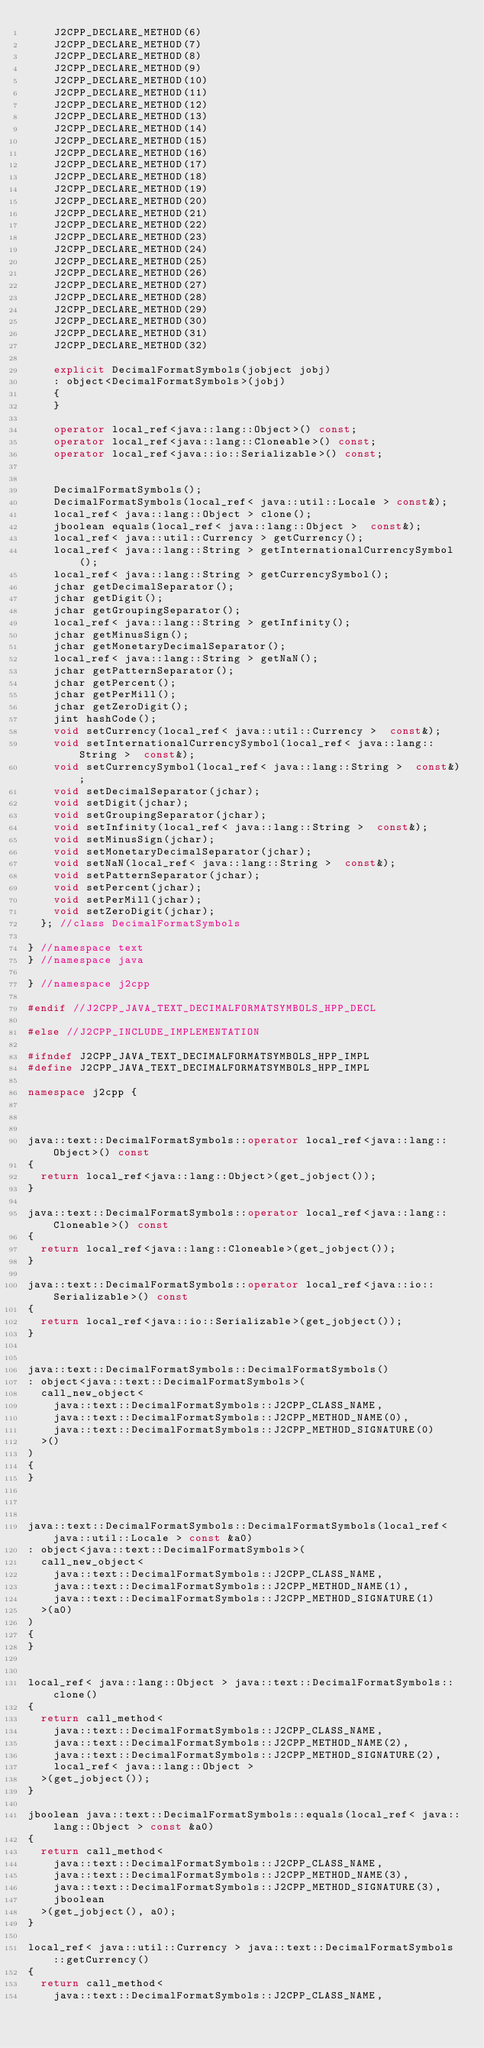<code> <loc_0><loc_0><loc_500><loc_500><_C++_>		J2CPP_DECLARE_METHOD(6)
		J2CPP_DECLARE_METHOD(7)
		J2CPP_DECLARE_METHOD(8)
		J2CPP_DECLARE_METHOD(9)
		J2CPP_DECLARE_METHOD(10)
		J2CPP_DECLARE_METHOD(11)
		J2CPP_DECLARE_METHOD(12)
		J2CPP_DECLARE_METHOD(13)
		J2CPP_DECLARE_METHOD(14)
		J2CPP_DECLARE_METHOD(15)
		J2CPP_DECLARE_METHOD(16)
		J2CPP_DECLARE_METHOD(17)
		J2CPP_DECLARE_METHOD(18)
		J2CPP_DECLARE_METHOD(19)
		J2CPP_DECLARE_METHOD(20)
		J2CPP_DECLARE_METHOD(21)
		J2CPP_DECLARE_METHOD(22)
		J2CPP_DECLARE_METHOD(23)
		J2CPP_DECLARE_METHOD(24)
		J2CPP_DECLARE_METHOD(25)
		J2CPP_DECLARE_METHOD(26)
		J2CPP_DECLARE_METHOD(27)
		J2CPP_DECLARE_METHOD(28)
		J2CPP_DECLARE_METHOD(29)
		J2CPP_DECLARE_METHOD(30)
		J2CPP_DECLARE_METHOD(31)
		J2CPP_DECLARE_METHOD(32)

		explicit DecimalFormatSymbols(jobject jobj)
		: object<DecimalFormatSymbols>(jobj)
		{
		}

		operator local_ref<java::lang::Object>() const;
		operator local_ref<java::lang::Cloneable>() const;
		operator local_ref<java::io::Serializable>() const;


		DecimalFormatSymbols();
		DecimalFormatSymbols(local_ref< java::util::Locale > const&);
		local_ref< java::lang::Object > clone();
		jboolean equals(local_ref< java::lang::Object >  const&);
		local_ref< java::util::Currency > getCurrency();
		local_ref< java::lang::String > getInternationalCurrencySymbol();
		local_ref< java::lang::String > getCurrencySymbol();
		jchar getDecimalSeparator();
		jchar getDigit();
		jchar getGroupingSeparator();
		local_ref< java::lang::String > getInfinity();
		jchar getMinusSign();
		jchar getMonetaryDecimalSeparator();
		local_ref< java::lang::String > getNaN();
		jchar getPatternSeparator();
		jchar getPercent();
		jchar getPerMill();
		jchar getZeroDigit();
		jint hashCode();
		void setCurrency(local_ref< java::util::Currency >  const&);
		void setInternationalCurrencySymbol(local_ref< java::lang::String >  const&);
		void setCurrencySymbol(local_ref< java::lang::String >  const&);
		void setDecimalSeparator(jchar);
		void setDigit(jchar);
		void setGroupingSeparator(jchar);
		void setInfinity(local_ref< java::lang::String >  const&);
		void setMinusSign(jchar);
		void setMonetaryDecimalSeparator(jchar);
		void setNaN(local_ref< java::lang::String >  const&);
		void setPatternSeparator(jchar);
		void setPercent(jchar);
		void setPerMill(jchar);
		void setZeroDigit(jchar);
	}; //class DecimalFormatSymbols

} //namespace text
} //namespace java

} //namespace j2cpp

#endif //J2CPP_JAVA_TEXT_DECIMALFORMATSYMBOLS_HPP_DECL

#else //J2CPP_INCLUDE_IMPLEMENTATION

#ifndef J2CPP_JAVA_TEXT_DECIMALFORMATSYMBOLS_HPP_IMPL
#define J2CPP_JAVA_TEXT_DECIMALFORMATSYMBOLS_HPP_IMPL

namespace j2cpp {



java::text::DecimalFormatSymbols::operator local_ref<java::lang::Object>() const
{
	return local_ref<java::lang::Object>(get_jobject());
}

java::text::DecimalFormatSymbols::operator local_ref<java::lang::Cloneable>() const
{
	return local_ref<java::lang::Cloneable>(get_jobject());
}

java::text::DecimalFormatSymbols::operator local_ref<java::io::Serializable>() const
{
	return local_ref<java::io::Serializable>(get_jobject());
}


java::text::DecimalFormatSymbols::DecimalFormatSymbols()
: object<java::text::DecimalFormatSymbols>(
	call_new_object<
		java::text::DecimalFormatSymbols::J2CPP_CLASS_NAME,
		java::text::DecimalFormatSymbols::J2CPP_METHOD_NAME(0),
		java::text::DecimalFormatSymbols::J2CPP_METHOD_SIGNATURE(0)
	>()
)
{
}



java::text::DecimalFormatSymbols::DecimalFormatSymbols(local_ref< java::util::Locale > const &a0)
: object<java::text::DecimalFormatSymbols>(
	call_new_object<
		java::text::DecimalFormatSymbols::J2CPP_CLASS_NAME,
		java::text::DecimalFormatSymbols::J2CPP_METHOD_NAME(1),
		java::text::DecimalFormatSymbols::J2CPP_METHOD_SIGNATURE(1)
	>(a0)
)
{
}


local_ref< java::lang::Object > java::text::DecimalFormatSymbols::clone()
{
	return call_method<
		java::text::DecimalFormatSymbols::J2CPP_CLASS_NAME,
		java::text::DecimalFormatSymbols::J2CPP_METHOD_NAME(2),
		java::text::DecimalFormatSymbols::J2CPP_METHOD_SIGNATURE(2), 
		local_ref< java::lang::Object >
	>(get_jobject());
}

jboolean java::text::DecimalFormatSymbols::equals(local_ref< java::lang::Object > const &a0)
{
	return call_method<
		java::text::DecimalFormatSymbols::J2CPP_CLASS_NAME,
		java::text::DecimalFormatSymbols::J2CPP_METHOD_NAME(3),
		java::text::DecimalFormatSymbols::J2CPP_METHOD_SIGNATURE(3), 
		jboolean
	>(get_jobject(), a0);
}

local_ref< java::util::Currency > java::text::DecimalFormatSymbols::getCurrency()
{
	return call_method<
		java::text::DecimalFormatSymbols::J2CPP_CLASS_NAME,</code> 